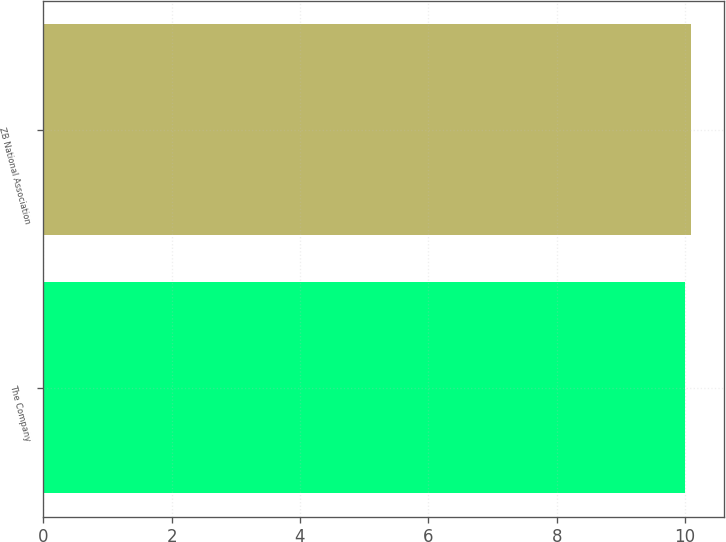Convert chart. <chart><loc_0><loc_0><loc_500><loc_500><bar_chart><fcel>The Company<fcel>ZB National Association<nl><fcel>10<fcel>10.1<nl></chart> 